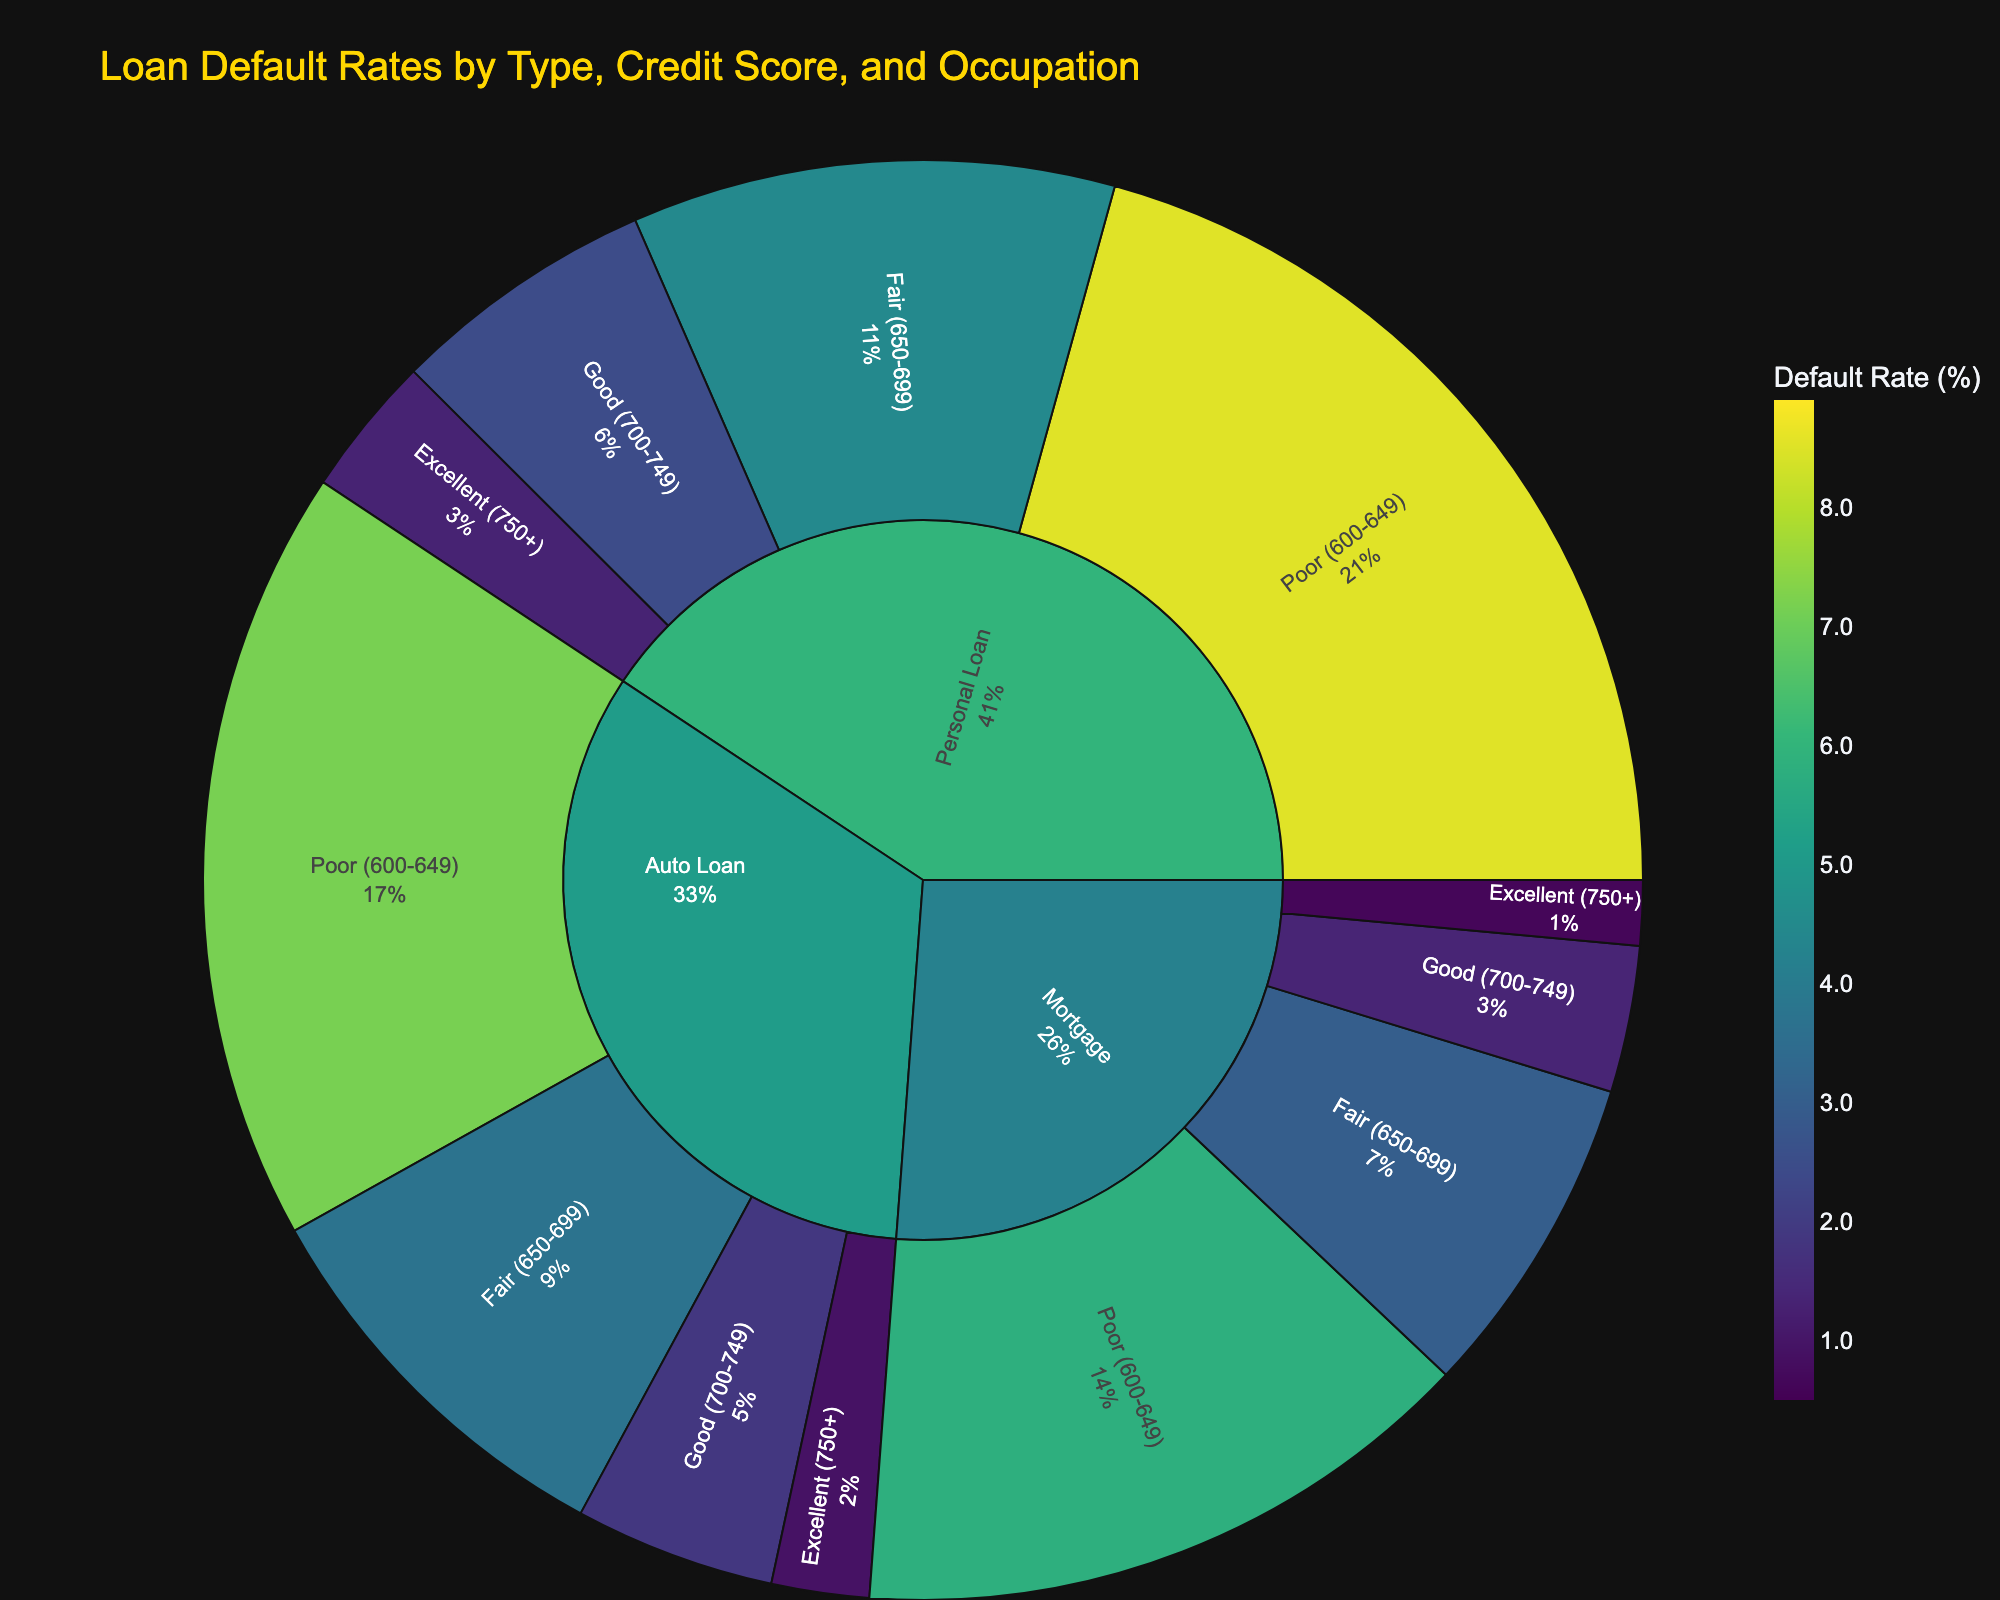What is the title of the Sunburst Plot? The title of the Sunburst Plot is displayed at the top center of the figure. You can read it directly from there.
Answer: Loan Default Rates by Type, Credit Score, and Occupation Which loan type has the highest overall default rate? To find the loan type with the highest overall default rate, look at the colored sections in the chart corresponding to each loan type and compare the default rates.
Answer: Personal Loan What is the default rate range for "Good (700-749)" credit scores in the "Mortgage" loan type? In the "Mortgage" loan type, navigate to the section representing "Good (700-749)" credit scores, and check the default rates of the occupations listed under this category.
Answer: 1.2% to 1.5% How does the default rate of "Mortgage" loans for "Excellent (750+)" credit scores compare to "Personal Loan" for the same credit score range? Locate the "Mortgage" and "Personal Loan" sections, then look under the "Excellent (750+)" credit score range for each and compare the default rates shown for the related occupations.
Answer: Mortgage has lower default rates (0.5% to 0.7%) compared to Personal Loans (1.2% to 1.4%) What is the highest default rate for occupations under "Auto Loan - Poor (600-649)" credit score range? Find the section for "Auto Loan" and then navigate down to "Poor (600-649)" credit scores. Identify the default rates for the occupations listed and select the highest one.
Answer: 7.5% Which occupation has the highest default rate in the "Personal Loan" category? Go to the "Personal Loan" section, then navigate through the credit score ranges to identify and compare the default rates for all occupations listed.
Answer: Bartender (8.9%) What is the average default rate for "Fair (650-699)" credit scores across all loan types? Identify all the default rates for "Fair (650-699)" credit scores in each loan type, sum them up, and divide by the number of occupations to calculate the average.
Answer: (2.8 + 3.2 + 3.5 + 3.9 + 4.2 + 4.7) / 6 = 3.88% Compare the default rates for engineers between "Mortgage" and "Personal Loan" categories. Locate the engineer occupation in both "Mortgage" and "Personal Loan" categories and check the default rates provided for each. Note that engineers are only listed in the "Mortgage" category, so comparison is not possible in this case.
Answer: N/A 